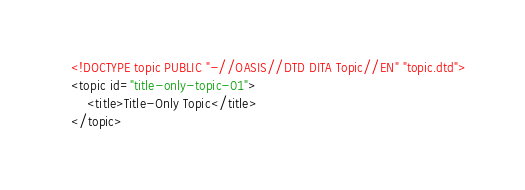<code> <loc_0><loc_0><loc_500><loc_500><_XML_><!DOCTYPE topic PUBLIC "-//OASIS//DTD DITA Topic//EN" "topic.dtd">
<topic id="title-only-topic-01">
    <title>Title-Only Topic</title>
</topic>
</code> 